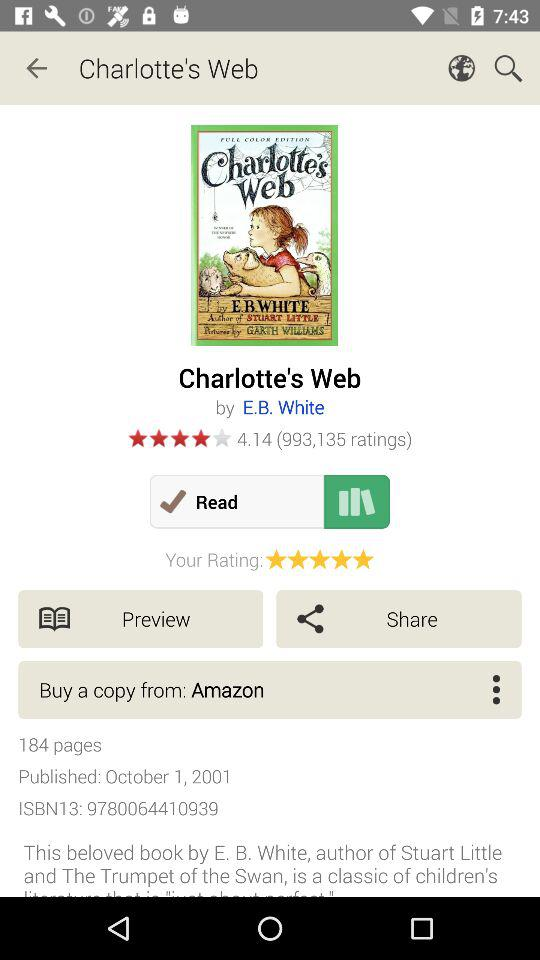How many people have rated the book? The book has been rated by 993,135 people. 